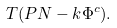<formula> <loc_0><loc_0><loc_500><loc_500>T ( P N - k \Phi ^ { c } ) .</formula> 